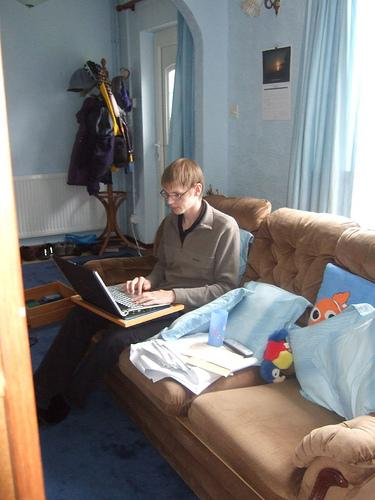The fish on the pillow goes by what name? Please explain your reasoning. nemo. An orange clown fish is on a pillow on a couch. 